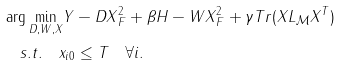<formula> <loc_0><loc_0><loc_500><loc_500>& \arg \underset { D , W , X } { \min } \| Y - D X \| _ { F } ^ { 2 } + \beta \| H - W X \| _ { F } ^ { 2 } + \gamma T r ( X L _ { \mathcal { M } } X ^ { T } ) \\ & \quad s . t . \quad \| x _ { i } \| _ { 0 } \leq T \quad \forall i .</formula> 